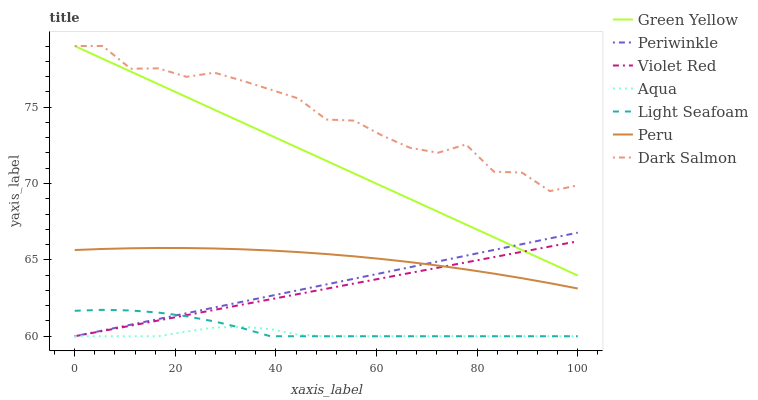Does Aqua have the minimum area under the curve?
Answer yes or no. Yes. Does Dark Salmon have the maximum area under the curve?
Answer yes or no. Yes. Does Light Seafoam have the minimum area under the curve?
Answer yes or no. No. Does Light Seafoam have the maximum area under the curve?
Answer yes or no. No. Is Green Yellow the smoothest?
Answer yes or no. Yes. Is Dark Salmon the roughest?
Answer yes or no. Yes. Is Light Seafoam the smoothest?
Answer yes or no. No. Is Light Seafoam the roughest?
Answer yes or no. No. Does Violet Red have the lowest value?
Answer yes or no. Yes. Does Dark Salmon have the lowest value?
Answer yes or no. No. Does Green Yellow have the highest value?
Answer yes or no. Yes. Does Light Seafoam have the highest value?
Answer yes or no. No. Is Peru less than Dark Salmon?
Answer yes or no. Yes. Is Green Yellow greater than Light Seafoam?
Answer yes or no. Yes. Does Violet Red intersect Periwinkle?
Answer yes or no. Yes. Is Violet Red less than Periwinkle?
Answer yes or no. No. Is Violet Red greater than Periwinkle?
Answer yes or no. No. Does Peru intersect Dark Salmon?
Answer yes or no. No. 